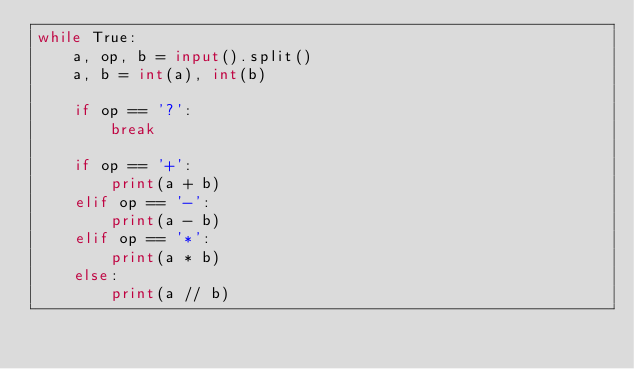Convert code to text. <code><loc_0><loc_0><loc_500><loc_500><_Python_>while True:
    a, op, b = input().split()
    a, b = int(a), int(b)

    if op == '?':
        break

    if op == '+':
        print(a + b)
    elif op == '-':
        print(a - b)
    elif op == '*':
        print(a * b)
    else:
        print(a // b)

</code> 